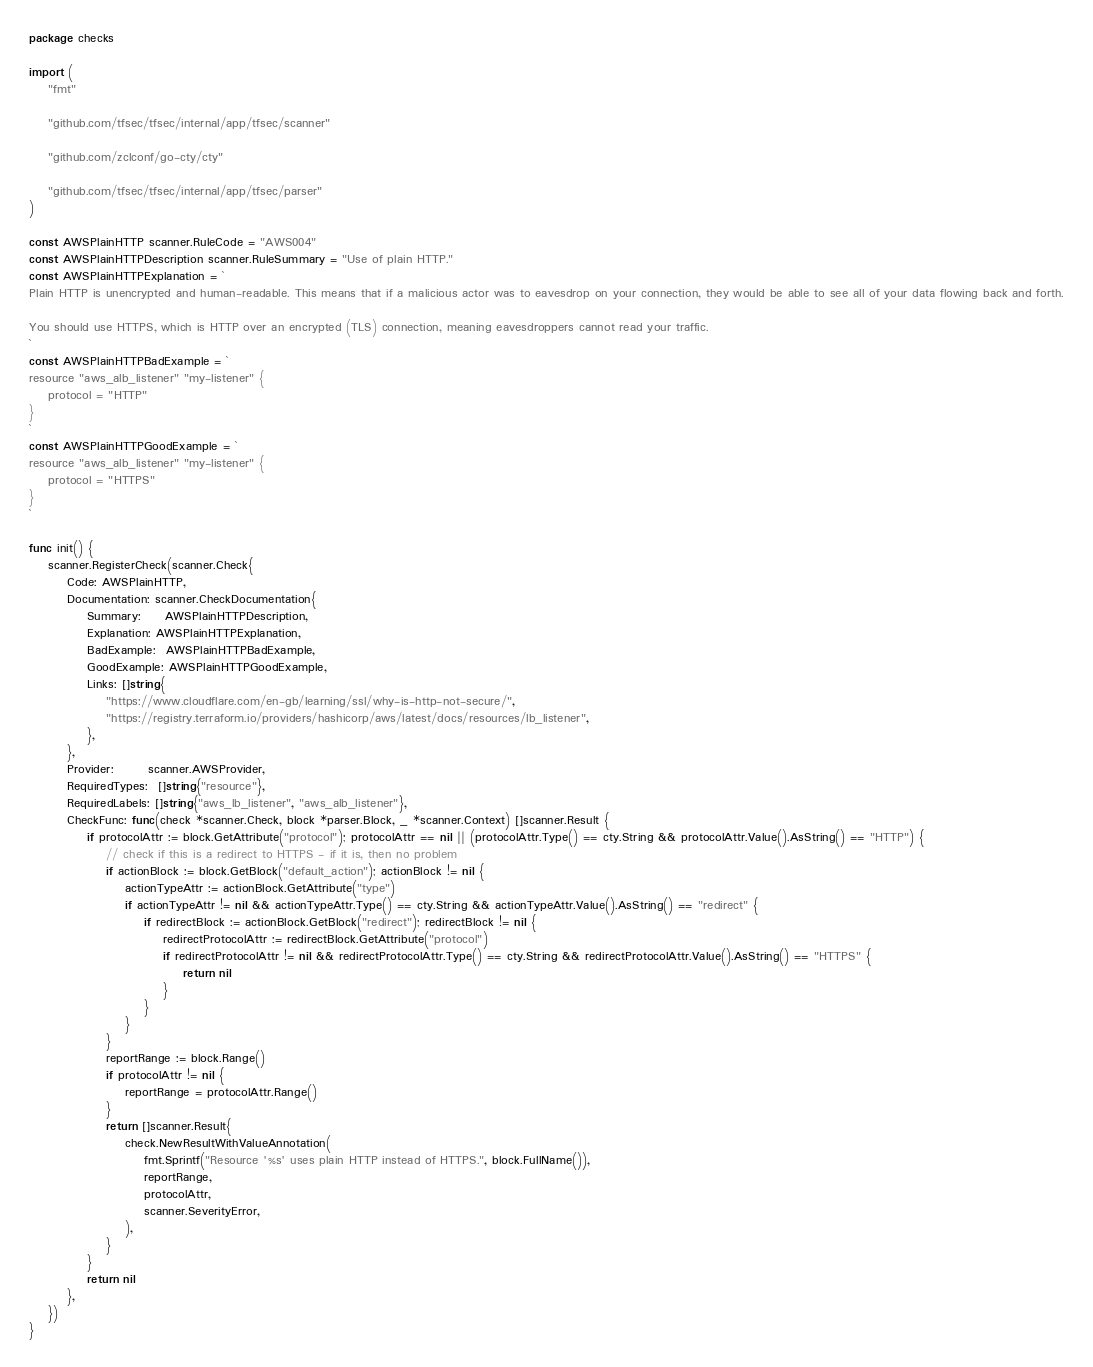Convert code to text. <code><loc_0><loc_0><loc_500><loc_500><_Go_>package checks

import (
	"fmt"

	"github.com/tfsec/tfsec/internal/app/tfsec/scanner"

	"github.com/zclconf/go-cty/cty"

	"github.com/tfsec/tfsec/internal/app/tfsec/parser"
)

const AWSPlainHTTP scanner.RuleCode = "AWS004"
const AWSPlainHTTPDescription scanner.RuleSummary = "Use of plain HTTP."
const AWSPlainHTTPExplanation = `
Plain HTTP is unencrypted and human-readable. This means that if a malicious actor was to eavesdrop on your connection, they would be able to see all of your data flowing back and forth.

You should use HTTPS, which is HTTP over an encrypted (TLS) connection, meaning eavesdroppers cannot read your traffic.
`
const AWSPlainHTTPBadExample = `
resource "aws_alb_listener" "my-listener" {
	protocol = "HTTP"
}
`
const AWSPlainHTTPGoodExample = `
resource "aws_alb_listener" "my-listener" {
	protocol = "HTTPS"
}
`

func init() {
	scanner.RegisterCheck(scanner.Check{
		Code: AWSPlainHTTP,
		Documentation: scanner.CheckDocumentation{
			Summary:     AWSPlainHTTPDescription,
			Explanation: AWSPlainHTTPExplanation,
			BadExample:  AWSPlainHTTPBadExample,
			GoodExample: AWSPlainHTTPGoodExample,
			Links: []string{
				"https://www.cloudflare.com/en-gb/learning/ssl/why-is-http-not-secure/",
				"https://registry.terraform.io/providers/hashicorp/aws/latest/docs/resources/lb_listener",
			},
		},
		Provider:       scanner.AWSProvider,
		RequiredTypes:  []string{"resource"},
		RequiredLabels: []string{"aws_lb_listener", "aws_alb_listener"},
		CheckFunc: func(check *scanner.Check, block *parser.Block, _ *scanner.Context) []scanner.Result {
			if protocolAttr := block.GetAttribute("protocol"); protocolAttr == nil || (protocolAttr.Type() == cty.String && protocolAttr.Value().AsString() == "HTTP") {
				// check if this is a redirect to HTTPS - if it is, then no problem
				if actionBlock := block.GetBlock("default_action"); actionBlock != nil {
					actionTypeAttr := actionBlock.GetAttribute("type")
					if actionTypeAttr != nil && actionTypeAttr.Type() == cty.String && actionTypeAttr.Value().AsString() == "redirect" {
						if redirectBlock := actionBlock.GetBlock("redirect"); redirectBlock != nil {
							redirectProtocolAttr := redirectBlock.GetAttribute("protocol")
							if redirectProtocolAttr != nil && redirectProtocolAttr.Type() == cty.String && redirectProtocolAttr.Value().AsString() == "HTTPS" {
								return nil
							}
						}
					}
				}
				reportRange := block.Range()
				if protocolAttr != nil {
					reportRange = protocolAttr.Range()
				}
				return []scanner.Result{
					check.NewResultWithValueAnnotation(
						fmt.Sprintf("Resource '%s' uses plain HTTP instead of HTTPS.", block.FullName()),
						reportRange,
						protocolAttr,
						scanner.SeverityError,
					),
				}
			}
			return nil
		},
	})
}
</code> 